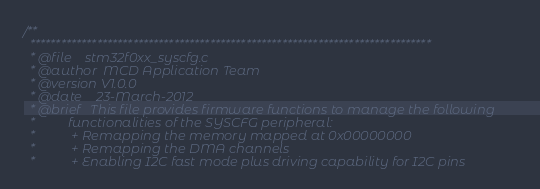<code> <loc_0><loc_0><loc_500><loc_500><_C_>/**
  ******************************************************************************
  * @file    stm32f0xx_syscfg.c
  * @author  MCD Application Team
  * @version V1.0.0
  * @date    23-March-2012
  * @brief   This file provides firmware functions to manage the following 
  *          functionalities of the SYSCFG peripheral:
  *           + Remapping the memory mapped at 0x00000000  
  *           + Remapping the DMA channels
  *           + Enabling I2C fast mode plus driving capability for I2C pins   </code> 